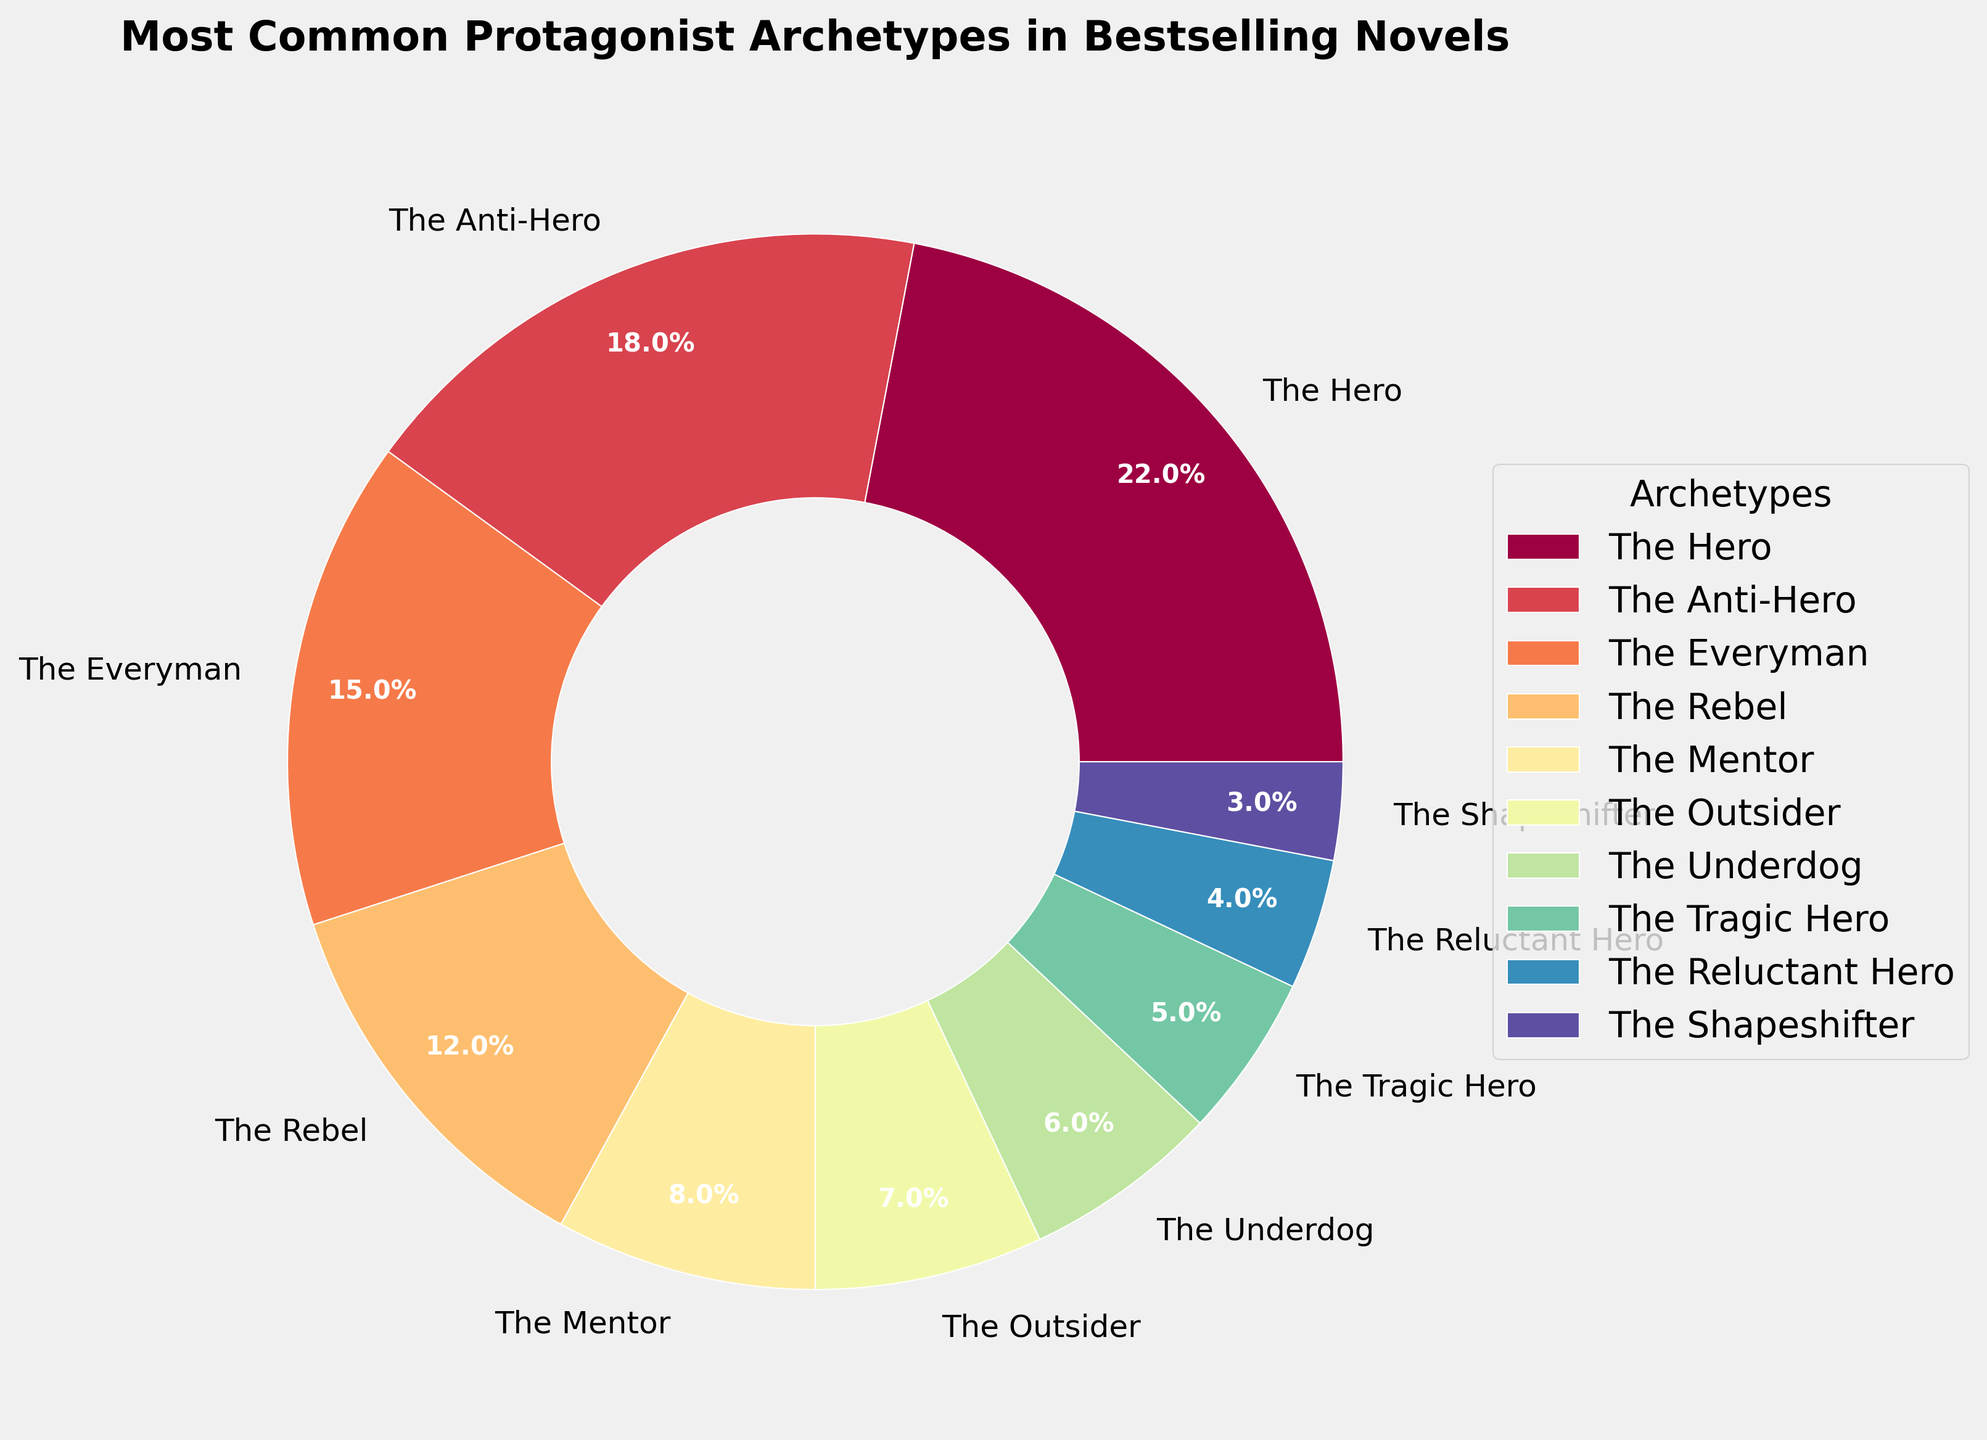What is the most common protagonist archetype in bestselling novels? The pie chart shows different protagonist archetypes along with their corresponding percentages. By observing the largest segment, we can identify "The Hero" as the most common archetype.
Answer: The Hero How much larger is the percentage of "The Hero" compared to "The Anti-Hero"? "The Hero" accounts for 22%, while "The Anti-Hero" accounts for 18%. We calculate the difference as 22% - 18% = 4%.
Answer: 4% Which protagonist archetypes together make up exactly 50% of the total? By summing the percentages, we see that "The Hero" (22%) and "The Anti-Hero" (18%) together make 40%, and adding "The Everyman" (15%) overshoots 50%. For exactly 50%, the combination is "The Hero" (22%), "The Anti-Hero" (18%), and "The Mentor" (8%), which sum to 22% + 18% + 8% = 48%. Adding "The Outsider" (7%) would be 55%, which is too high. No exact combination sums to 50% without exceeding it.
Answer: None Is the sum of "The Tragic Hero" and "The Reluctant Hero" greater or less than "The Everyman"? "The Tragic Hero" is 5% and "The Reluctant Hero" is 4%. Their total is 5% + 4% = 9%, which is less than "The Everyman's" 15%.
Answer: Less 